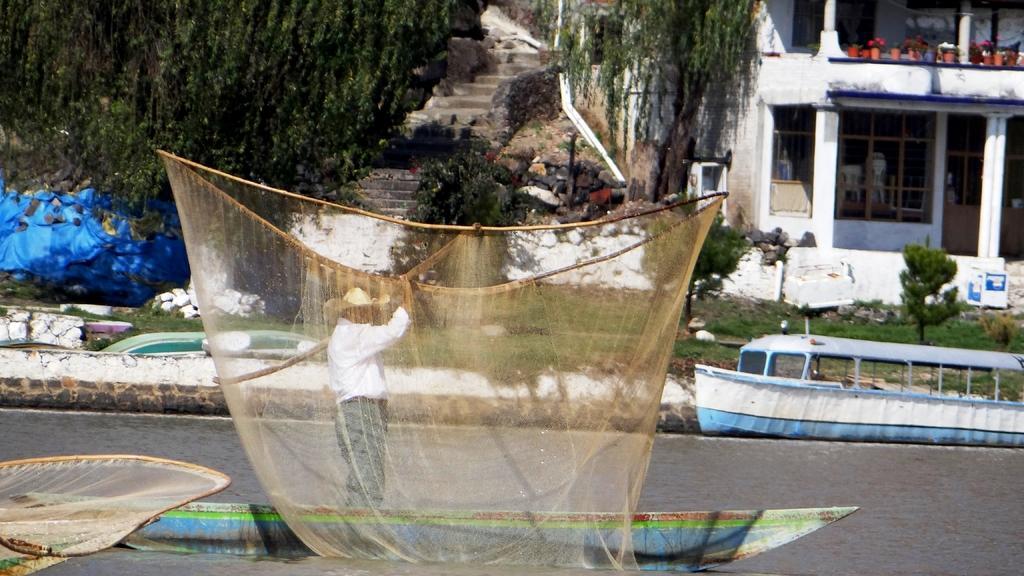Could you give a brief overview of what you see in this image? In the image on the water there is a boat. On the boat there is a man standing and holding the net in his hands. Behind him on the boat there is a net. Behind the boat there is another boat on the water. In the background there are plants, trees and on the right side of the image there is a building with walls, glass windows and pillars. And also there are steps, plants and trees on the left side of the image. 